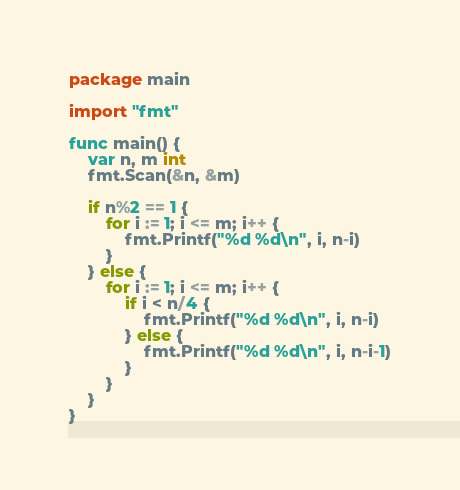<code> <loc_0><loc_0><loc_500><loc_500><_Go_>package main

import "fmt"

func main() {
	var n, m int
	fmt.Scan(&n, &m)

	if n%2 == 1 {
		for i := 1; i <= m; i++ {
			fmt.Printf("%d %d\n", i, n-i)
		}
	} else {
		for i := 1; i <= m; i++ {
			if i < n/4 {
				fmt.Printf("%d %d\n", i, n-i)
			} else {
				fmt.Printf("%d %d\n", i, n-i-1)
			}
		}
	}
}
</code> 